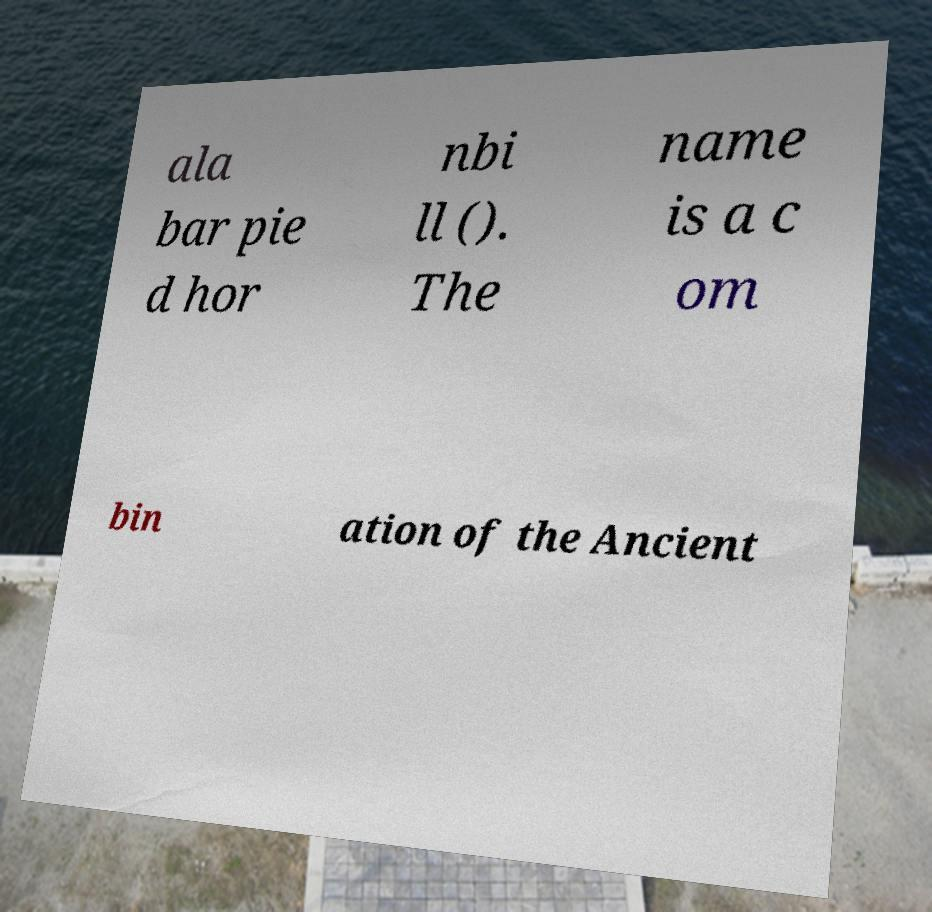What messages or text are displayed in this image? I need them in a readable, typed format. ala bar pie d hor nbi ll (). The name is a c om bin ation of the Ancient 